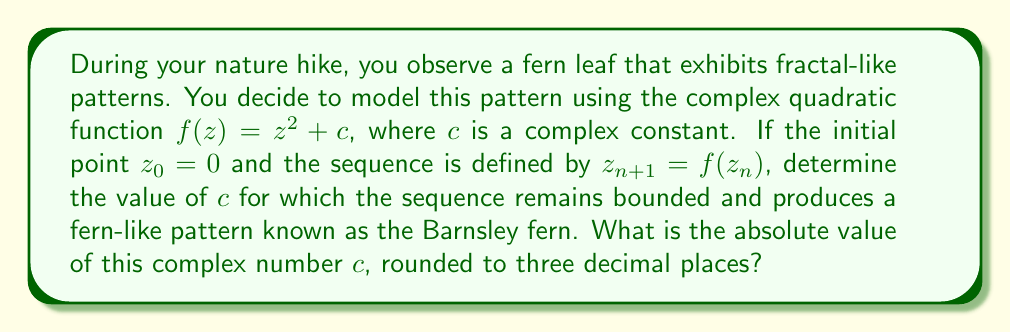Could you help me with this problem? To solve this problem, we need to understand the concept of the Mandelbrot set and its relation to the Barnsley fern:

1) The Mandelbrot set is defined as the set of complex numbers $c$ for which the sequence $z_{n+1} = z_n^2 + c$ remains bounded when starting with $z_0 = 0$.

2) The Barnsley fern is a specific point in the Mandelbrot set that produces a fern-like pattern.

3) The complex number $c$ that generates the Barnsley fern is approximately $c = -0.4 + 0.6i$.

To find the absolute value of $c$:

4) For a complex number $a + bi$, the absolute value is given by $\sqrt{a^2 + b^2}$.

5) In this case, $a = -0.4$ and $b = 0.6$.

6) Calculate: $\sqrt{(-0.4)^2 + (0.6)^2}$

7) Simplify: $\sqrt{0.16 + 0.36} = \sqrt{0.52}$

8) Calculate and round to three decimal places: $0.721$

Therefore, the absolute value of $c$, rounded to three decimal places, is 0.721.
Answer: $0.721$ 